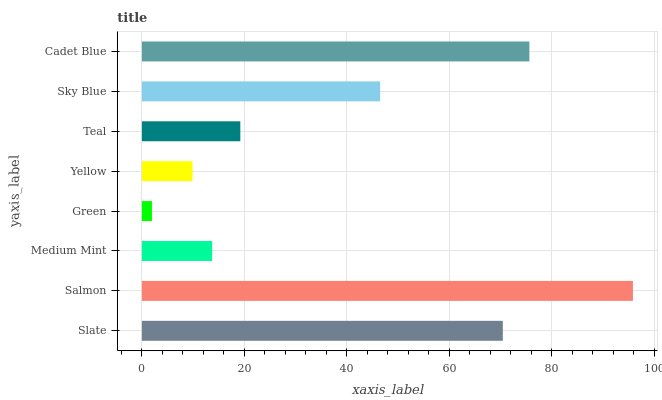Is Green the minimum?
Answer yes or no. Yes. Is Salmon the maximum?
Answer yes or no. Yes. Is Medium Mint the minimum?
Answer yes or no. No. Is Medium Mint the maximum?
Answer yes or no. No. Is Salmon greater than Medium Mint?
Answer yes or no. Yes. Is Medium Mint less than Salmon?
Answer yes or no. Yes. Is Medium Mint greater than Salmon?
Answer yes or no. No. Is Salmon less than Medium Mint?
Answer yes or no. No. Is Sky Blue the high median?
Answer yes or no. Yes. Is Teal the low median?
Answer yes or no. Yes. Is Green the high median?
Answer yes or no. No. Is Yellow the low median?
Answer yes or no. No. 